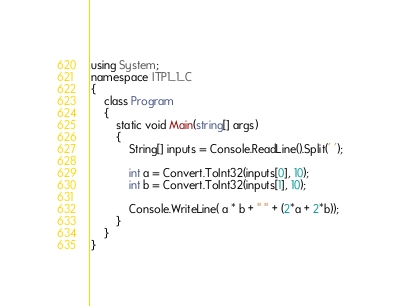Convert code to text. <code><loc_0><loc_0><loc_500><loc_500><_C#_>using System;
namespace ITP1_1_C
{
    class Program
    {
        static void Main(string[] args)
        {
            String[] inputs = Console.ReadLine().Split(' ');

            int a = Convert.ToInt32(inputs[0], 10);
            int b = Convert.ToInt32(inputs[1], 10);

            Console.WriteLine( a * b + " " + (2*a + 2*b));
        }
    }
}</code> 